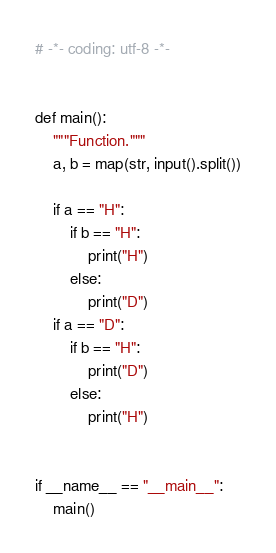Convert code to text. <code><loc_0><loc_0><loc_500><loc_500><_Python_># -*- coding: utf-8 -*-


def main():
    """Function."""
    a, b = map(str, input().split())

    if a == "H":
        if b == "H":
            print("H")
        else:
            print("D")
    if a == "D":
        if b == "H":
            print("D")
        else:
            print("H")


if __name__ == "__main__":
    main()
</code> 